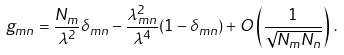<formula> <loc_0><loc_0><loc_500><loc_500>g _ { m n } = \frac { N _ { m } } { \lambda ^ { 2 } } \delta _ { m n } - \frac { \lambda _ { m n } ^ { 2 } } { \lambda ^ { 4 } } ( 1 - \delta _ { m n } ) + O \left ( \frac { 1 } { \sqrt { N _ { m } N _ { n } } } \right ) \, .</formula> 